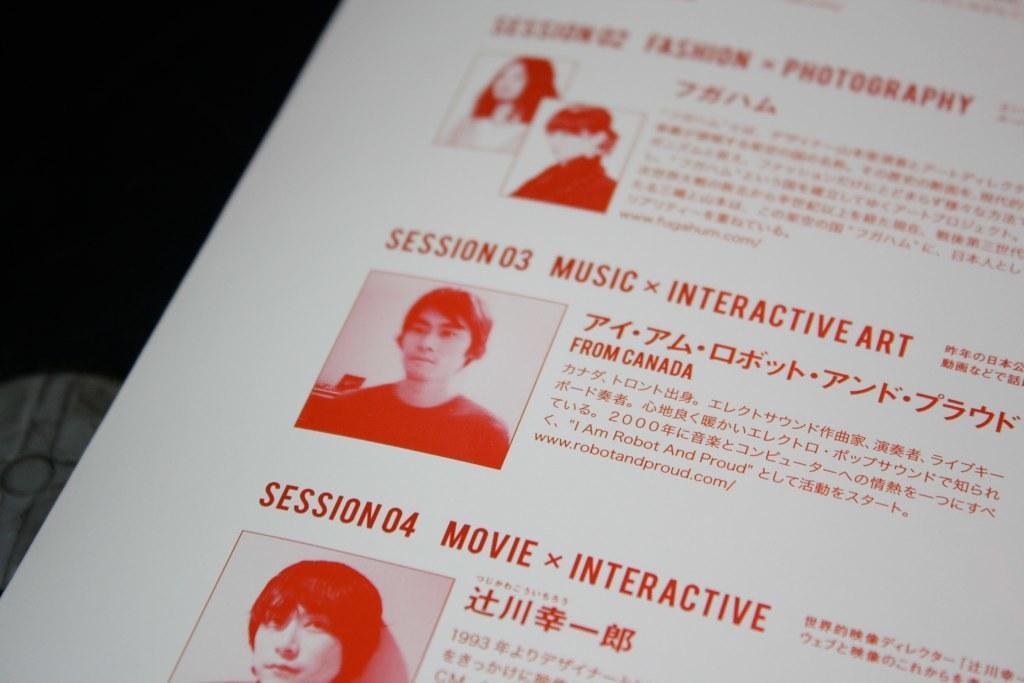Can you describe this image briefly? In the image there is a paper. On paper there are few images and also there is something written on it. 